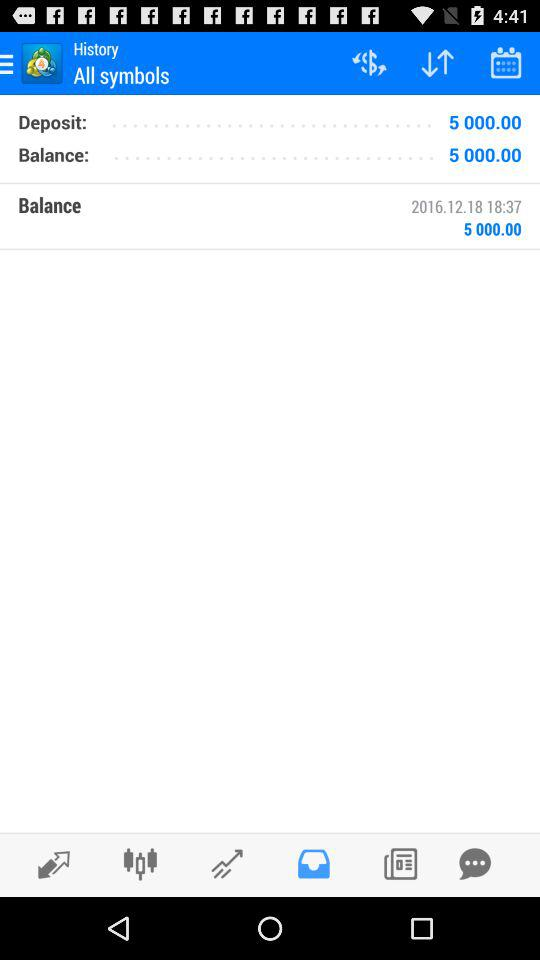What is the date? The date is 2016.12.18. 